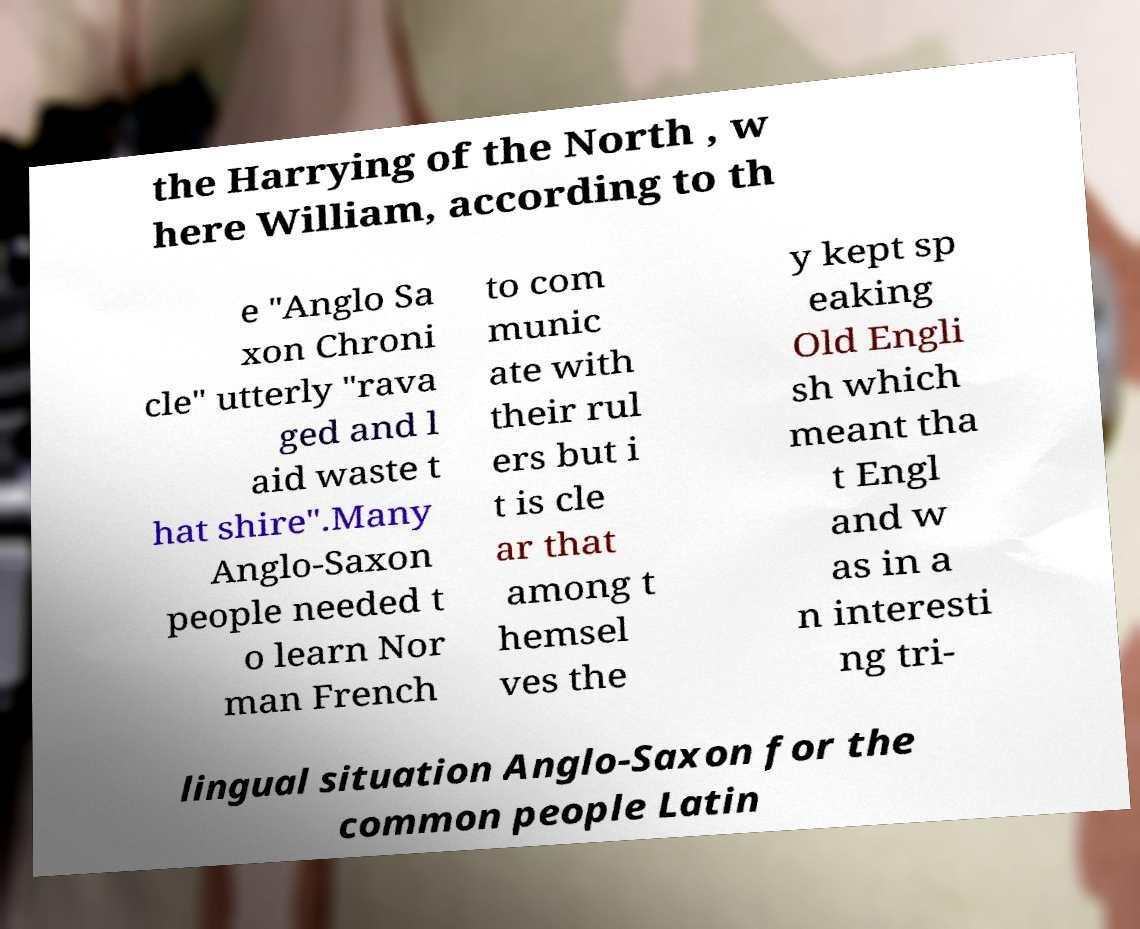There's text embedded in this image that I need extracted. Can you transcribe it verbatim? the Harrying of the North , w here William, according to th e "Anglo Sa xon Chroni cle" utterly "rava ged and l aid waste t hat shire".Many Anglo-Saxon people needed t o learn Nor man French to com munic ate with their rul ers but i t is cle ar that among t hemsel ves the y kept sp eaking Old Engli sh which meant tha t Engl and w as in a n interesti ng tri- lingual situation Anglo-Saxon for the common people Latin 